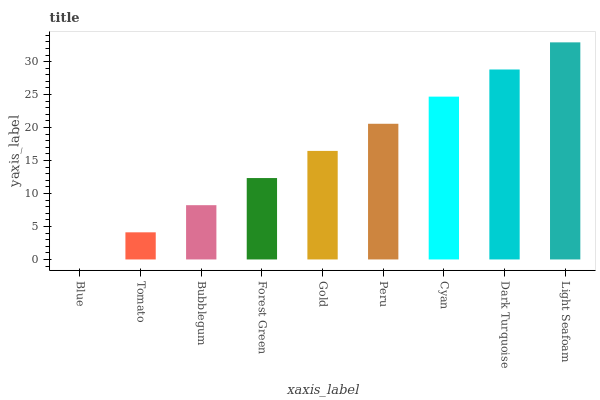Is Blue the minimum?
Answer yes or no. Yes. Is Light Seafoam the maximum?
Answer yes or no. Yes. Is Tomato the minimum?
Answer yes or no. No. Is Tomato the maximum?
Answer yes or no. No. Is Tomato greater than Blue?
Answer yes or no. Yes. Is Blue less than Tomato?
Answer yes or no. Yes. Is Blue greater than Tomato?
Answer yes or no. No. Is Tomato less than Blue?
Answer yes or no. No. Is Gold the high median?
Answer yes or no. Yes. Is Gold the low median?
Answer yes or no. Yes. Is Dark Turquoise the high median?
Answer yes or no. No. Is Forest Green the low median?
Answer yes or no. No. 